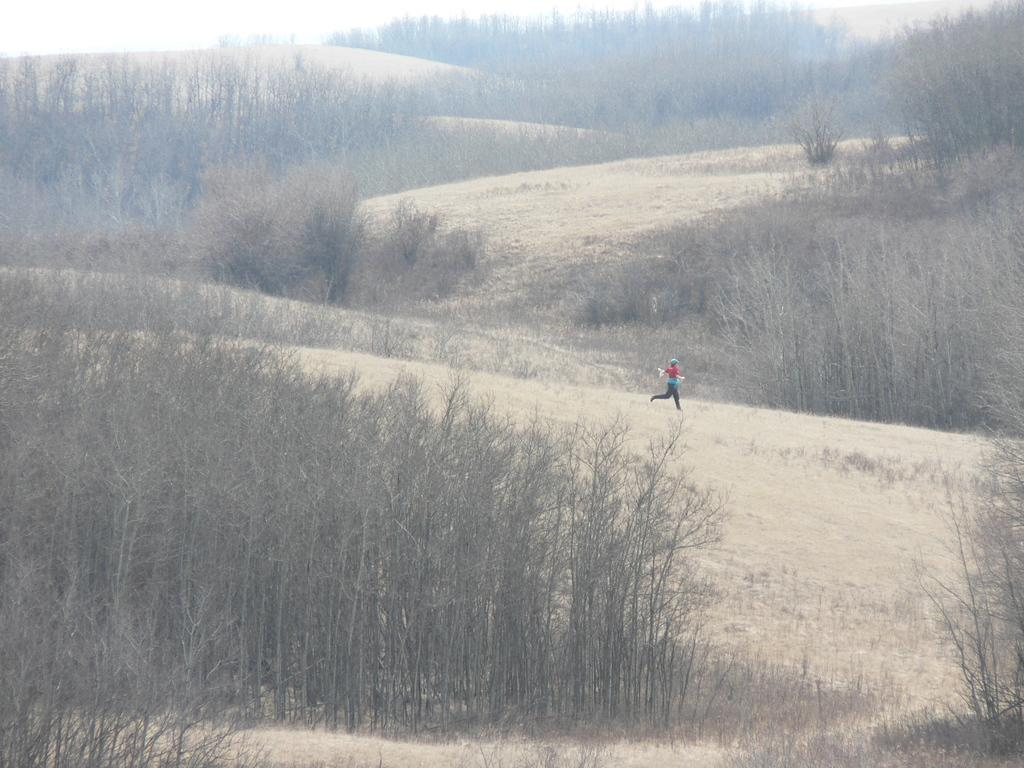What type of vegetation can be seen in the image? There are trees in the image. What is the person in the image doing? There is a person running in the image. What type of education is being exchanged between the trees in the image? There is no education or exchange present in the image; it features trees and a person running. What source of power is being utilized by the person running in the image? There is no indication of a power source in the image; the person is simply running. 